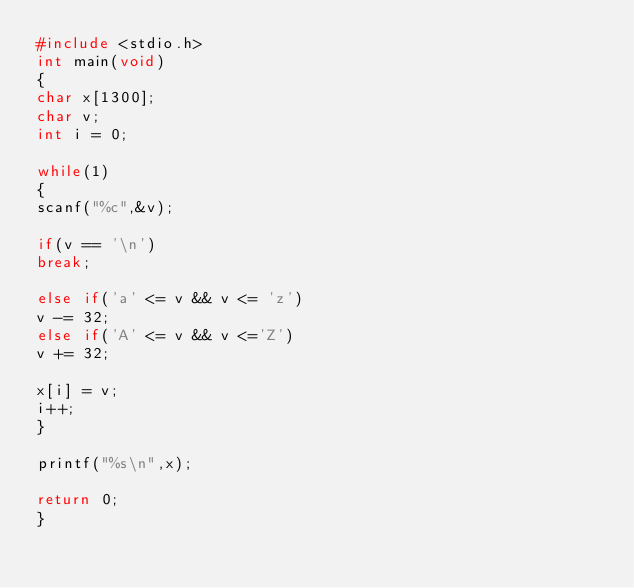<code> <loc_0><loc_0><loc_500><loc_500><_C_>#include <stdio.h>
int main(void)
{
char x[1300];
char v;
int i = 0;
 
while(1)
{
scanf("%c",&v);
 
if(v == '\n')
break;
 
else if('a' <= v && v <= 'z')
v -= 32;
else if('A' <= v && v <='Z')
v += 32;
 
x[i] = v;
i++;
}
 
printf("%s\n",x);
 
return 0;
}</code> 